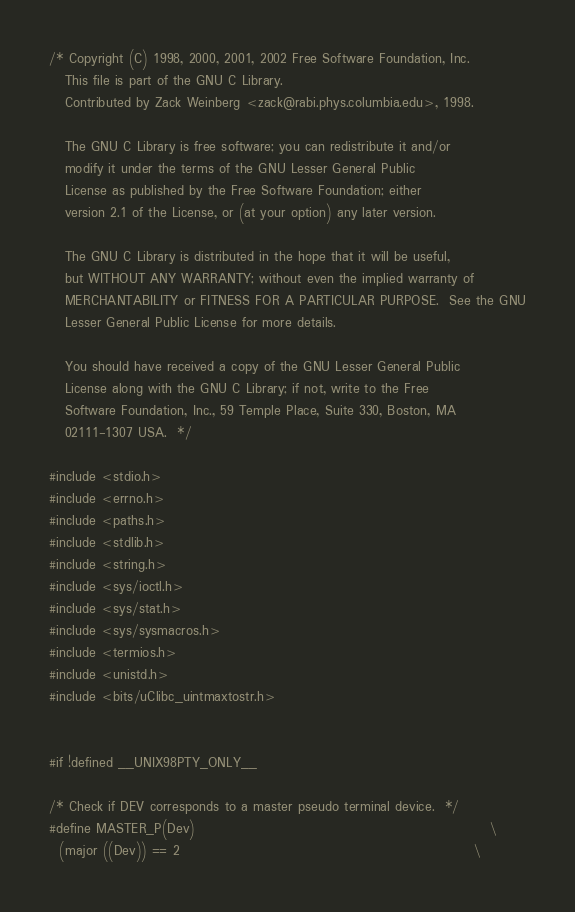<code> <loc_0><loc_0><loc_500><loc_500><_C_>/* Copyright (C) 1998, 2000, 2001, 2002 Free Software Foundation, Inc.
   This file is part of the GNU C Library.
   Contributed by Zack Weinberg <zack@rabi.phys.columbia.edu>, 1998.

   The GNU C Library is free software; you can redistribute it and/or
   modify it under the terms of the GNU Lesser General Public
   License as published by the Free Software Foundation; either
   version 2.1 of the License, or (at your option) any later version.

   The GNU C Library is distributed in the hope that it will be useful,
   but WITHOUT ANY WARRANTY; without even the implied warranty of
   MERCHANTABILITY or FITNESS FOR A PARTICULAR PURPOSE.  See the GNU
   Lesser General Public License for more details.

   You should have received a copy of the GNU Lesser General Public
   License along with the GNU C Library; if not, write to the Free
   Software Foundation, Inc., 59 Temple Place, Suite 330, Boston, MA
   02111-1307 USA.  */

#include <stdio.h>
#include <errno.h>
#include <paths.h>
#include <stdlib.h>
#include <string.h>
#include <sys/ioctl.h>
#include <sys/stat.h>
#include <sys/sysmacros.h>
#include <termios.h>
#include <unistd.h>
#include <bits/uClibc_uintmaxtostr.h>


#if !defined __UNIX98PTY_ONLY__

/* Check if DEV corresponds to a master pseudo terminal device.  */
#define MASTER_P(Dev)                                                         \
  (major ((Dev)) == 2                                                         \</code> 